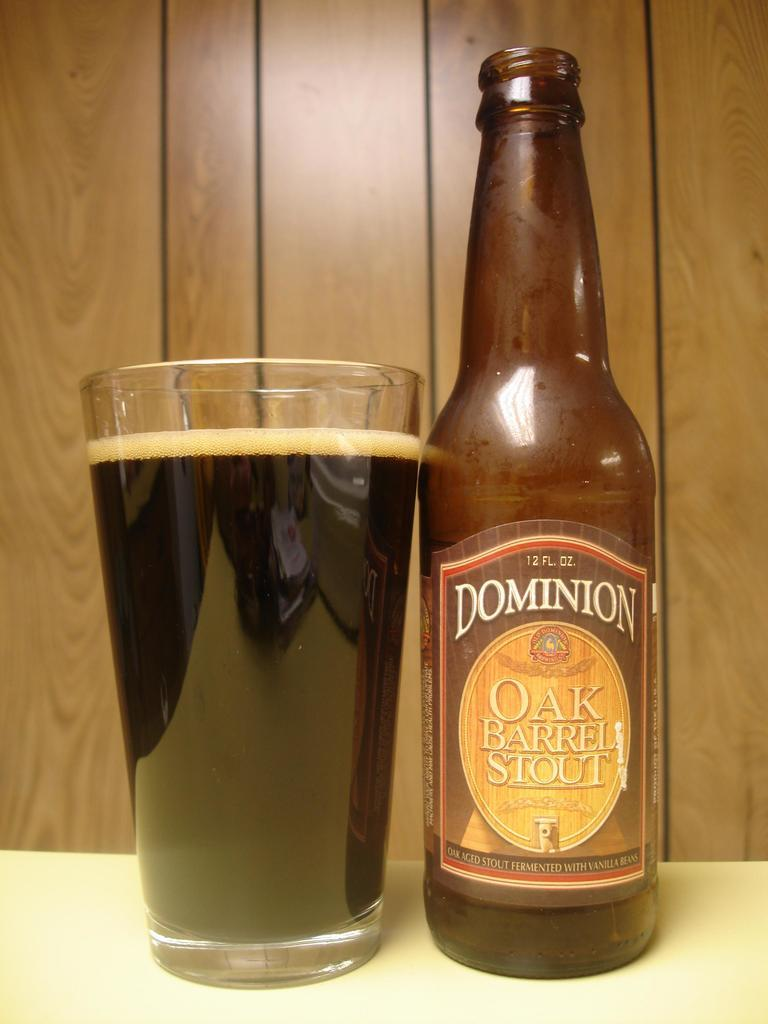<image>
Render a clear and concise summary of the photo. A glass full of Dominion Oak Barrel Stout with open bottle beside it. 